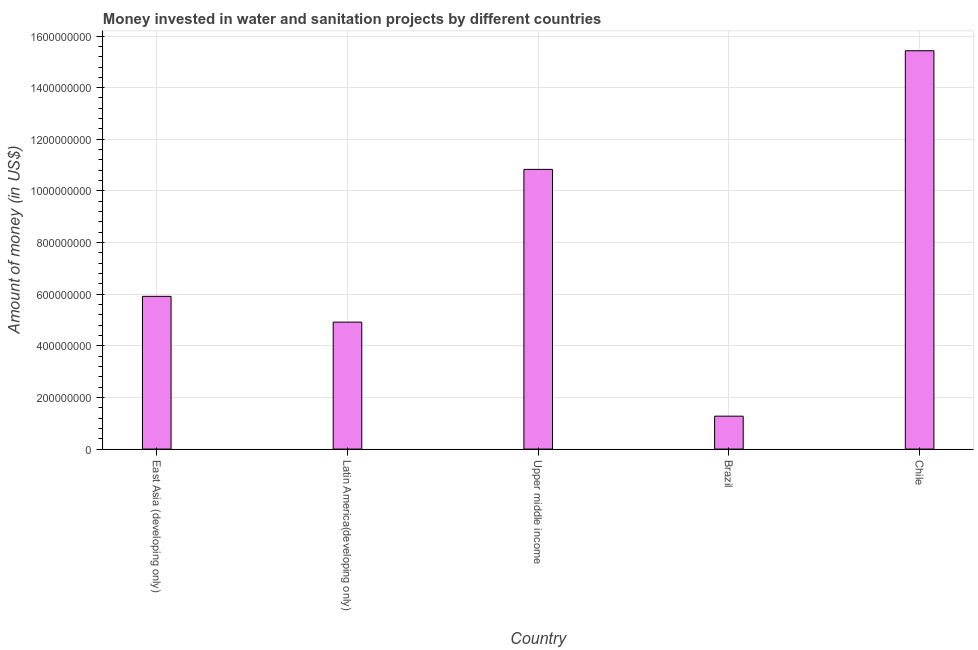What is the title of the graph?
Provide a short and direct response. Money invested in water and sanitation projects by different countries. What is the label or title of the Y-axis?
Make the answer very short. Amount of money (in US$). What is the investment in Latin America(developing only)?
Keep it short and to the point. 4.92e+08. Across all countries, what is the maximum investment?
Keep it short and to the point. 1.54e+09. Across all countries, what is the minimum investment?
Your answer should be very brief. 1.28e+08. In which country was the investment maximum?
Offer a terse response. Chile. What is the sum of the investment?
Your answer should be very brief. 3.84e+09. What is the difference between the investment in East Asia (developing only) and Latin America(developing only)?
Provide a succinct answer. 9.98e+07. What is the average investment per country?
Offer a very short reply. 7.67e+08. What is the median investment?
Your response must be concise. 5.92e+08. In how many countries, is the investment greater than 1240000000 US$?
Your response must be concise. 1. What is the ratio of the investment in Brazil to that in Chile?
Make the answer very short. 0.08. Is the investment in Brazil less than that in East Asia (developing only)?
Your response must be concise. Yes. What is the difference between the highest and the second highest investment?
Your answer should be compact. 4.60e+08. What is the difference between the highest and the lowest investment?
Offer a very short reply. 1.42e+09. In how many countries, is the investment greater than the average investment taken over all countries?
Your response must be concise. 2. How many bars are there?
Offer a very short reply. 5. What is the difference between two consecutive major ticks on the Y-axis?
Ensure brevity in your answer.  2.00e+08. Are the values on the major ticks of Y-axis written in scientific E-notation?
Your answer should be compact. No. What is the Amount of money (in US$) in East Asia (developing only)?
Your response must be concise. 5.92e+08. What is the Amount of money (in US$) in Latin America(developing only)?
Keep it short and to the point. 4.92e+08. What is the Amount of money (in US$) in Upper middle income?
Offer a terse response. 1.08e+09. What is the Amount of money (in US$) in Brazil?
Give a very brief answer. 1.28e+08. What is the Amount of money (in US$) of Chile?
Keep it short and to the point. 1.54e+09. What is the difference between the Amount of money (in US$) in East Asia (developing only) and Latin America(developing only)?
Offer a terse response. 9.98e+07. What is the difference between the Amount of money (in US$) in East Asia (developing only) and Upper middle income?
Give a very brief answer. -4.92e+08. What is the difference between the Amount of money (in US$) in East Asia (developing only) and Brazil?
Provide a short and direct response. 4.64e+08. What is the difference between the Amount of money (in US$) in East Asia (developing only) and Chile?
Provide a short and direct response. -9.51e+08. What is the difference between the Amount of money (in US$) in Latin America(developing only) and Upper middle income?
Make the answer very short. -5.92e+08. What is the difference between the Amount of money (in US$) in Latin America(developing only) and Brazil?
Offer a very short reply. 3.64e+08. What is the difference between the Amount of money (in US$) in Latin America(developing only) and Chile?
Your answer should be very brief. -1.05e+09. What is the difference between the Amount of money (in US$) in Upper middle income and Brazil?
Make the answer very short. 9.56e+08. What is the difference between the Amount of money (in US$) in Upper middle income and Chile?
Ensure brevity in your answer.  -4.60e+08. What is the difference between the Amount of money (in US$) in Brazil and Chile?
Your answer should be very brief. -1.42e+09. What is the ratio of the Amount of money (in US$) in East Asia (developing only) to that in Latin America(developing only)?
Provide a succinct answer. 1.2. What is the ratio of the Amount of money (in US$) in East Asia (developing only) to that in Upper middle income?
Keep it short and to the point. 0.55. What is the ratio of the Amount of money (in US$) in East Asia (developing only) to that in Brazil?
Your answer should be very brief. 4.64. What is the ratio of the Amount of money (in US$) in East Asia (developing only) to that in Chile?
Offer a terse response. 0.38. What is the ratio of the Amount of money (in US$) in Latin America(developing only) to that in Upper middle income?
Offer a very short reply. 0.45. What is the ratio of the Amount of money (in US$) in Latin America(developing only) to that in Brazil?
Provide a succinct answer. 3.86. What is the ratio of the Amount of money (in US$) in Latin America(developing only) to that in Chile?
Keep it short and to the point. 0.32. What is the ratio of the Amount of money (in US$) in Upper middle income to that in Brazil?
Offer a very short reply. 8.5. What is the ratio of the Amount of money (in US$) in Upper middle income to that in Chile?
Your answer should be very brief. 0.7. What is the ratio of the Amount of money (in US$) in Brazil to that in Chile?
Your answer should be very brief. 0.08. 